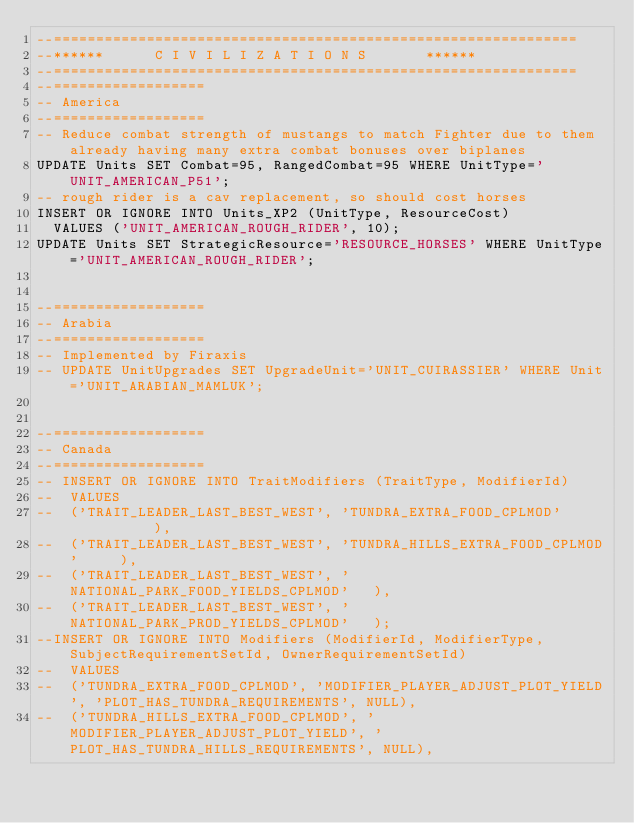Convert code to text. <code><loc_0><loc_0><loc_500><loc_500><_SQL_>--==============================================================
--******			C I V I L I Z A T I O N S			  ******
--==============================================================
--==================
-- America
--==================
-- Reduce combat strength of mustangs to match Fighter due to them already having many extra combat bonuses over biplanes
UPDATE Units SET Combat=95, RangedCombat=95 WHERE UnitType='UNIT_AMERICAN_P51';
-- rough rider is a cav replacement, so should cost horses
INSERT OR IGNORE INTO Units_XP2 (UnitType, ResourceCost)
	VALUES ('UNIT_AMERICAN_ROUGH_RIDER', 10);
UPDATE Units SET StrategicResource='RESOURCE_HORSES' WHERE UnitType='UNIT_AMERICAN_ROUGH_RIDER';


--==================
-- Arabia
--==================
-- Implemented by Firaxis
-- UPDATE UnitUpgrades SET UpgradeUnit='UNIT_CUIRASSIER' WHERE Unit='UNIT_ARABIAN_MAMLUK';


--==================
-- Canada
--==================
-- INSERT OR IGNORE INTO TraitModifiers (TraitType, ModifierId)
--	VALUES
--	('TRAIT_LEADER_LAST_BEST_WEST', 'TUNDRA_EXTRA_FOOD_CPLMOD'           ),
--	('TRAIT_LEADER_LAST_BEST_WEST', 'TUNDRA_HILLS_EXTRA_FOOD_CPLMOD'     ),
--	('TRAIT_LEADER_LAST_BEST_WEST', 'NATIONAL_PARK_FOOD_YIELDS_CPLMOD'   ),
--	('TRAIT_LEADER_LAST_BEST_WEST', 'NATIONAL_PARK_PROD_YIELDS_CPLMOD'   );
--INSERT OR IGNORE INTO Modifiers (ModifierId, ModifierType, SubjectRequirementSetId, OwnerRequirementSetId)
--	VALUES
--	('TUNDRA_EXTRA_FOOD_CPLMOD', 'MODIFIER_PLAYER_ADJUST_PLOT_YIELD', 'PLOT_HAS_TUNDRA_REQUIREMENTS', NULL),
--	('TUNDRA_HILLS_EXTRA_FOOD_CPLMOD', 'MODIFIER_PLAYER_ADJUST_PLOT_YIELD', 'PLOT_HAS_TUNDRA_HILLS_REQUIREMENTS', NULL),</code> 